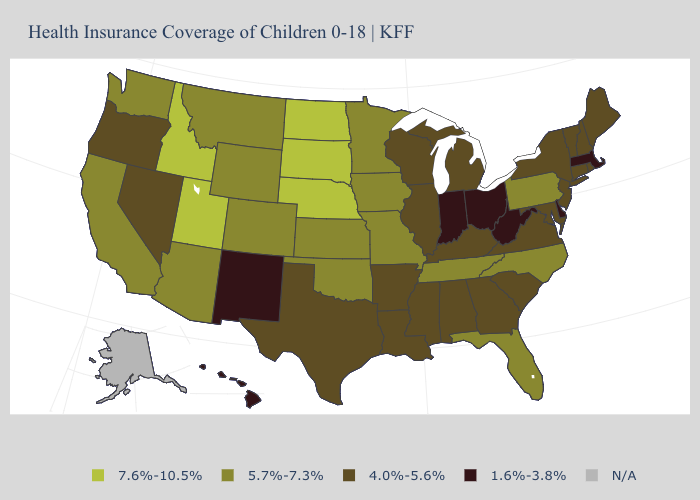What is the value of South Carolina?
Short answer required. 4.0%-5.6%. What is the value of South Dakota?
Concise answer only. 7.6%-10.5%. What is the lowest value in the USA?
Concise answer only. 1.6%-3.8%. Among the states that border Kansas , which have the highest value?
Answer briefly. Nebraska. What is the value of Nevada?
Write a very short answer. 4.0%-5.6%. What is the value of New Jersey?
Be succinct. 4.0%-5.6%. What is the value of Ohio?
Concise answer only. 1.6%-3.8%. Does Indiana have the lowest value in the USA?
Quick response, please. Yes. Does Idaho have the highest value in the West?
Concise answer only. Yes. Name the states that have a value in the range N/A?
Keep it brief. Alaska. Is the legend a continuous bar?
Keep it brief. No. Name the states that have a value in the range 1.6%-3.8%?
Keep it brief. Delaware, Hawaii, Indiana, Massachusetts, New Mexico, Ohio, West Virginia. Among the states that border Massachusetts , which have the lowest value?
Write a very short answer. Connecticut, New Hampshire, New York, Rhode Island, Vermont. Among the states that border Wisconsin , does Iowa have the highest value?
Give a very brief answer. Yes. Name the states that have a value in the range 5.7%-7.3%?
Keep it brief. Arizona, California, Colorado, Florida, Iowa, Kansas, Minnesota, Missouri, Montana, North Carolina, Oklahoma, Pennsylvania, Tennessee, Washington, Wyoming. 